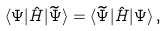Convert formula to latex. <formula><loc_0><loc_0><loc_500><loc_500>\langle \Psi | \hat { H } | \widetilde { \Psi } \rangle = \langle \widetilde { \Psi } | \hat { H } | \Psi \rangle \, ,</formula> 